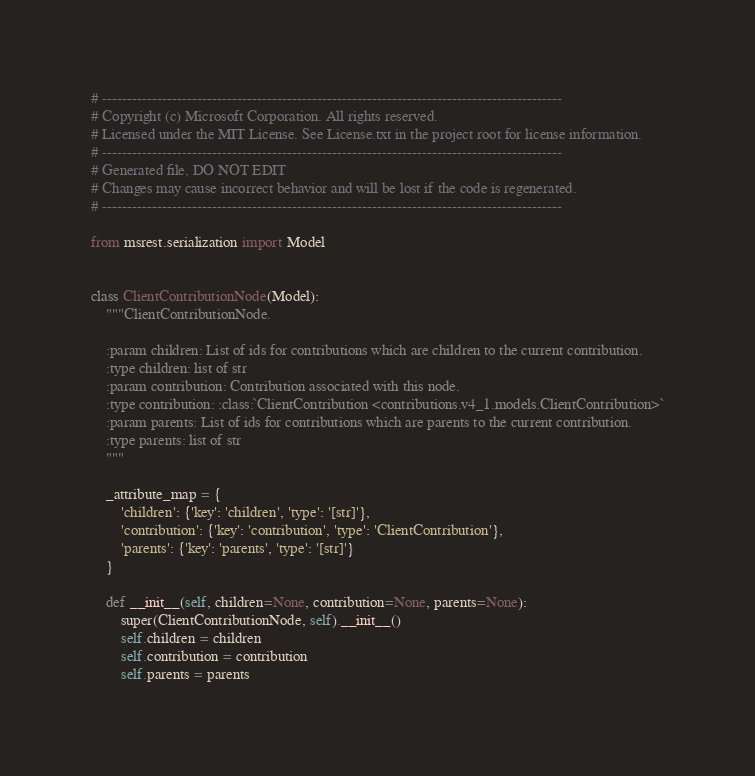<code> <loc_0><loc_0><loc_500><loc_500><_Python_># --------------------------------------------------------------------------------------------
# Copyright (c) Microsoft Corporation. All rights reserved.
# Licensed under the MIT License. See License.txt in the project root for license information.
# --------------------------------------------------------------------------------------------
# Generated file, DO NOT EDIT
# Changes may cause incorrect behavior and will be lost if the code is regenerated.
# --------------------------------------------------------------------------------------------

from msrest.serialization import Model


class ClientContributionNode(Model):
    """ClientContributionNode.

    :param children: List of ids for contributions which are children to the current contribution.
    :type children: list of str
    :param contribution: Contribution associated with this node.
    :type contribution: :class:`ClientContribution <contributions.v4_1.models.ClientContribution>`
    :param parents: List of ids for contributions which are parents to the current contribution.
    :type parents: list of str
    """

    _attribute_map = {
        'children': {'key': 'children', 'type': '[str]'},
        'contribution': {'key': 'contribution', 'type': 'ClientContribution'},
        'parents': {'key': 'parents', 'type': '[str]'}
    }

    def __init__(self, children=None, contribution=None, parents=None):
        super(ClientContributionNode, self).__init__()
        self.children = children
        self.contribution = contribution
        self.parents = parents
</code> 